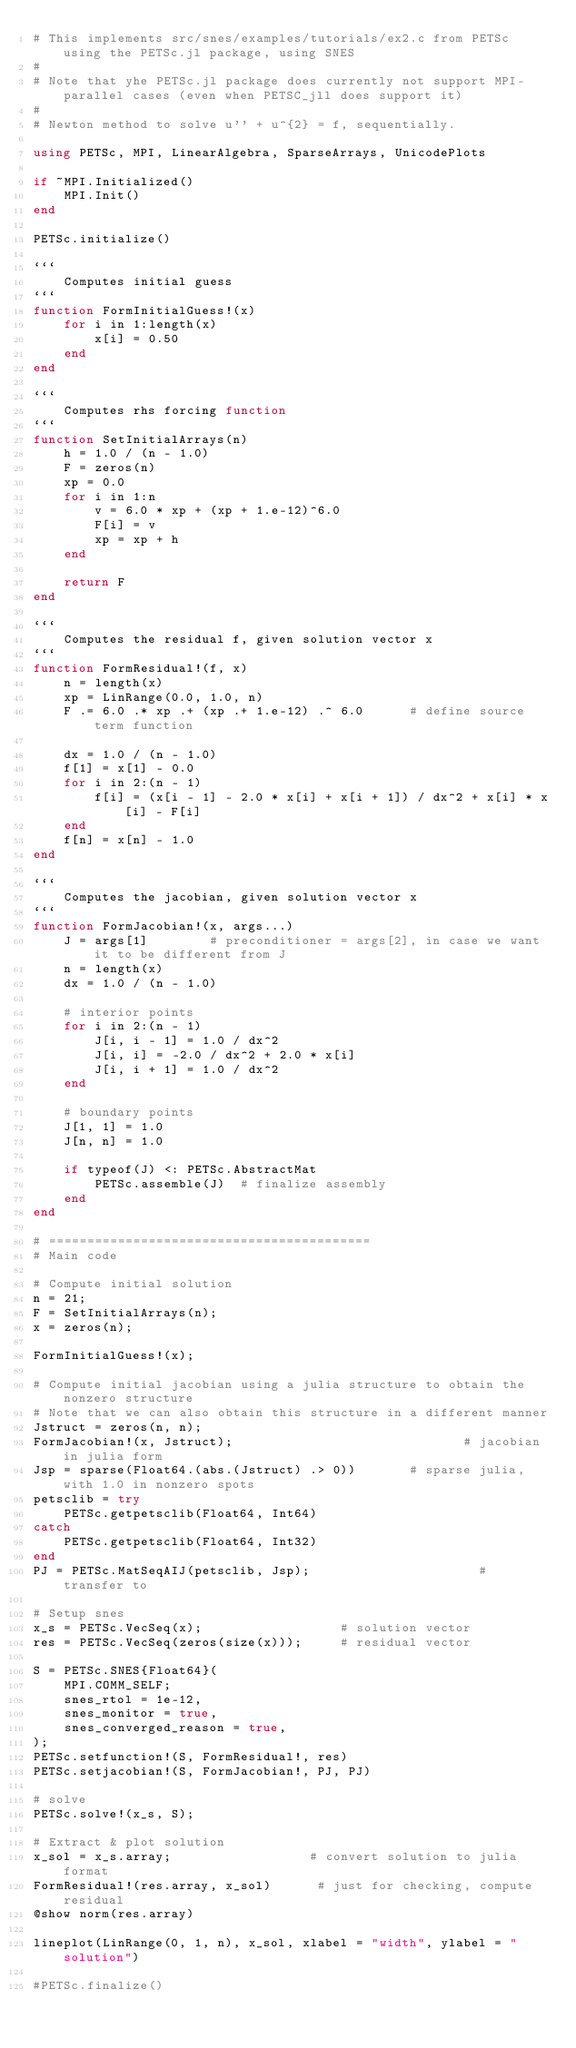<code> <loc_0><loc_0><loc_500><loc_500><_Julia_># This implements src/snes/examples/tutorials/ex2.c from PETSc using the PETSc.jl package, using SNES
#
# Note that yhe PETSc.jl package does currently not support MPI-parallel cases (even when PETSC_jll does support it)
#
# Newton method to solve u'' + u^{2} = f, sequentially.

using PETSc, MPI, LinearAlgebra, SparseArrays, UnicodePlots

if ~MPI.Initialized()
    MPI.Init()
end

PETSc.initialize()

```
    Computes initial guess 
```
function FormInitialGuess!(x)
    for i in 1:length(x)
        x[i] = 0.50
    end
end

```
    Computes rhs forcing function 
```
function SetInitialArrays(n)
    h = 1.0 / (n - 1.0)
    F = zeros(n)
    xp = 0.0
    for i in 1:n
        v = 6.0 * xp + (xp + 1.e-12)^6.0
        F[i] = v
        xp = xp + h
    end

    return F
end

```
    Computes the residual f, given solution vector x
```
function FormResidual!(f, x)
    n = length(x)
    xp = LinRange(0.0, 1.0, n)
    F .= 6.0 .* xp .+ (xp .+ 1.e-12) .^ 6.0      # define source term function

    dx = 1.0 / (n - 1.0)
    f[1] = x[1] - 0.0
    for i in 2:(n - 1)
        f[i] = (x[i - 1] - 2.0 * x[i] + x[i + 1]) / dx^2 + x[i] * x[i] - F[i]
    end
    f[n] = x[n] - 1.0
end

```
    Computes the jacobian, given solution vector x
```
function FormJacobian!(x, args...)
    J = args[1]        # preconditioner = args[2], in case we want it to be different from J
    n = length(x)
    dx = 1.0 / (n - 1.0)

    # interior points
    for i in 2:(n - 1)
        J[i, i - 1] = 1.0 / dx^2
        J[i, i] = -2.0 / dx^2 + 2.0 * x[i]
        J[i, i + 1] = 1.0 / dx^2
    end

    # boundary points
    J[1, 1] = 1.0
    J[n, n] = 1.0

    if typeof(J) <: PETSc.AbstractMat
        PETSc.assemble(J)  # finalize assembly
    end
end

# ==========================================
# Main code 

# Compute initial solution
n = 21;
F = SetInitialArrays(n);
x = zeros(n);

FormInitialGuess!(x);

# Compute initial jacobian using a julia structure to obtain the nonzero structure
# Note that we can also obtain this structure in a different manner
Jstruct = zeros(n, n);
FormJacobian!(x, Jstruct);                              # jacobian in julia form
Jsp = sparse(Float64.(abs.(Jstruct) .> 0))       # sparse julia, with 1.0 in nonzero spots
petsclib = try
    PETSc.getpetsclib(Float64, Int64)
catch
    PETSc.getpetsclib(Float64, Int32)
end
PJ = PETSc.MatSeqAIJ(petsclib, Jsp);                      # transfer to 

# Setup snes
x_s = PETSc.VecSeq(x);                  # solution vector
res = PETSc.VecSeq(zeros(size(x)));     # residual vector

S = PETSc.SNES{Float64}(
    MPI.COMM_SELF;
    snes_rtol = 1e-12,
    snes_monitor = true,
    snes_converged_reason = true,
);
PETSc.setfunction!(S, FormResidual!, res)
PETSc.setjacobian!(S, FormJacobian!, PJ, PJ)

# solve
PETSc.solve!(x_s, S);

# Extract & plot solution
x_sol = x_s.array;                  # convert solution to julia format
FormResidual!(res.array, x_sol)      # just for checking, compute residual
@show norm(res.array)

lineplot(LinRange(0, 1, n), x_sol, xlabel = "width", ylabel = "solution")

#PETSc.finalize()
</code> 